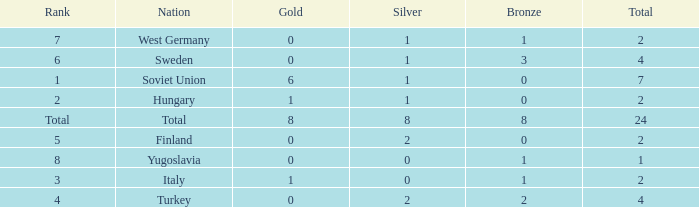What is the maximum total when gold equals 1, nation is hungary, and bronze is a negative value? None. 